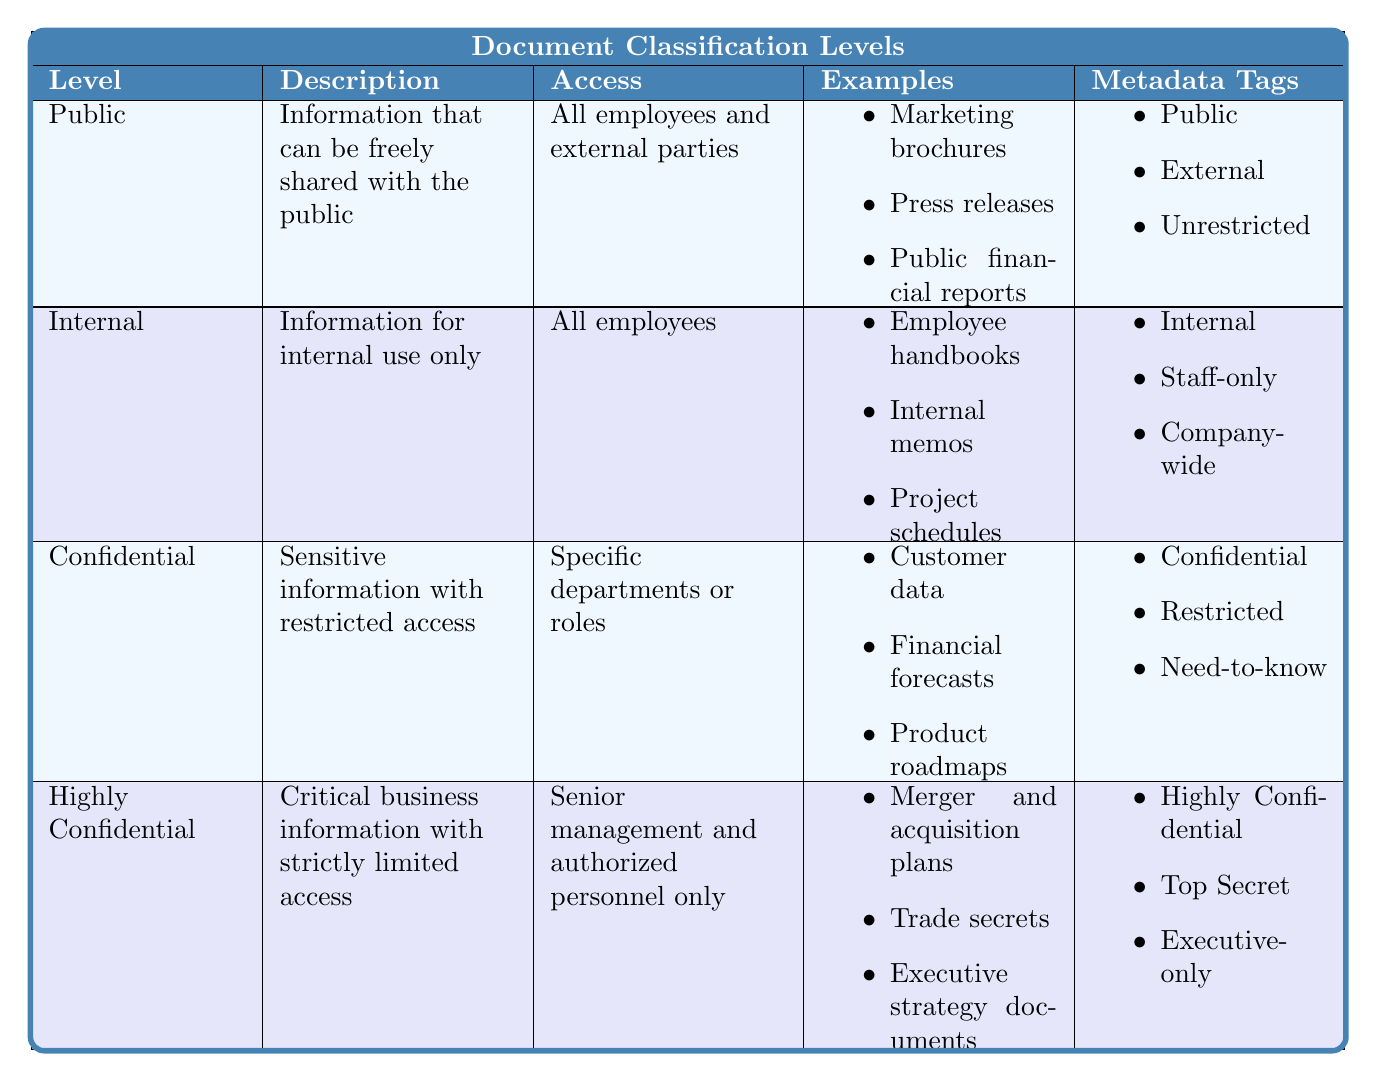What is the description of the "Confidential" classification level? The table provides a clear description for each classification level. For "Confidential," the description is "Sensitive information with restricted access."
Answer: Sensitive information with restricted access Which classification level allows access to all employees and external parties? By reviewing the "Access" column in the table, we find that "Public" classification level allows access to all employees and external parties.
Answer: Public How many examples are listed for the "Internal" classification level? The table lists three examples under the "Internal" classification level: "Employee handbooks," "Internal memos," and "Project schedules."
Answer: Three examples Is "Trade secrets" an example of "Public" documents? The table specifies that "Trade secrets" appear as an example under "Highly Confidential," not "Public," which indicates that this statement is false.
Answer: No For how long must "Highly Confidential" documents be retained? According to the retention policies outlined in the table, "Highly Confidential" documents have a retention duration of 10 years or are kept permanently.
Answer: 10 years or permanent What are the metadata tags associated with the "Confidential" classification level? The metadata tags for "Confidential" include "Confidential," "Restricted," and "Need-to-know." We find these tags listed in the corresponding row of the table.
Answer: Confidential, Restricted, Need-to-know How many classification levels have an access restriction to specific departments or roles? Upon examining the "Access" descriptions, we see that "Confidential" is the only classification level with this restriction. Thus, there is only one such level.
Answer: One level What is the main difference in access between "Internal" and "Highly Confidential"? The "Internal" classification level allows access to all employees, while the "Highly Confidential" allows access only to senior management and authorized personnel, indicating a major difference in access restrictions.
Answer: All employees vs. Senior management only Do "Public" documents require encryption? According to the encryption requirements in the table, "Public" documents have no encryption requirements, confirming the statement as true.
Answer: No What are the three main steps involved in the classification process? The classification process consists of four steps, and the first three are: Identify document sensitivity, Determine appropriate classification level, and Apply metadata tags. The last step is to Set access controls.
Answer: Identify sensitivity, Determine level, Apply tags 